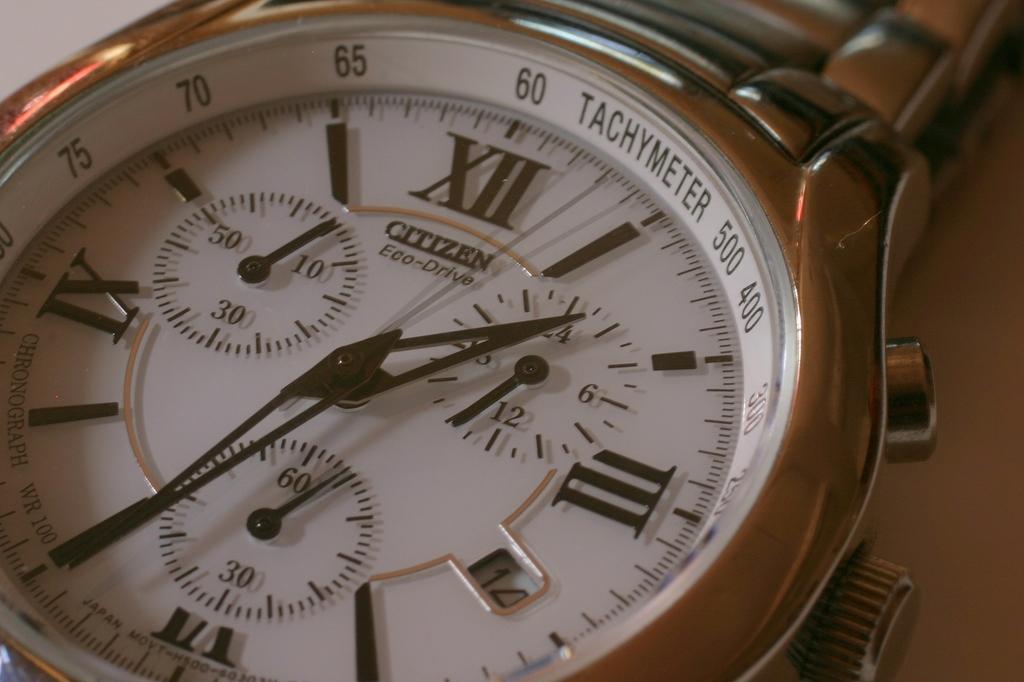What kind of watch is that?
Your answer should be compact. Citizen. What time is it on the watch?
Ensure brevity in your answer.  1:35. 